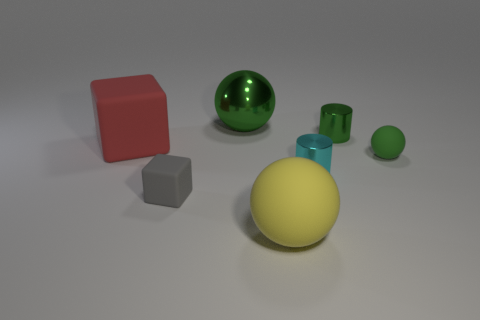Do the gray block and the big yellow ball have the same material?
Your response must be concise. Yes. What shape is the small gray thing?
Offer a very short reply. Cube. There is a rubber block left of the small rubber thing that is to the left of the big green sphere; how many cyan objects are in front of it?
Make the answer very short. 1. The other shiny thing that is the same shape as the yellow object is what color?
Provide a succinct answer. Green. What is the shape of the shiny object in front of the tiny rubber object that is on the right side of the green shiny thing in front of the metal ball?
Offer a terse response. Cylinder. How big is the object that is in front of the tiny cyan thing and to the left of the large yellow ball?
Offer a terse response. Small. Is the number of tiny green objects less than the number of yellow objects?
Ensure brevity in your answer.  No. What is the size of the rubber ball behind the gray rubber cube?
Offer a terse response. Small. There is a shiny object that is on the left side of the tiny green cylinder and behind the red matte block; what shape is it?
Keep it short and to the point. Sphere. What size is the green rubber object that is the same shape as the large metallic object?
Your answer should be very brief. Small. 